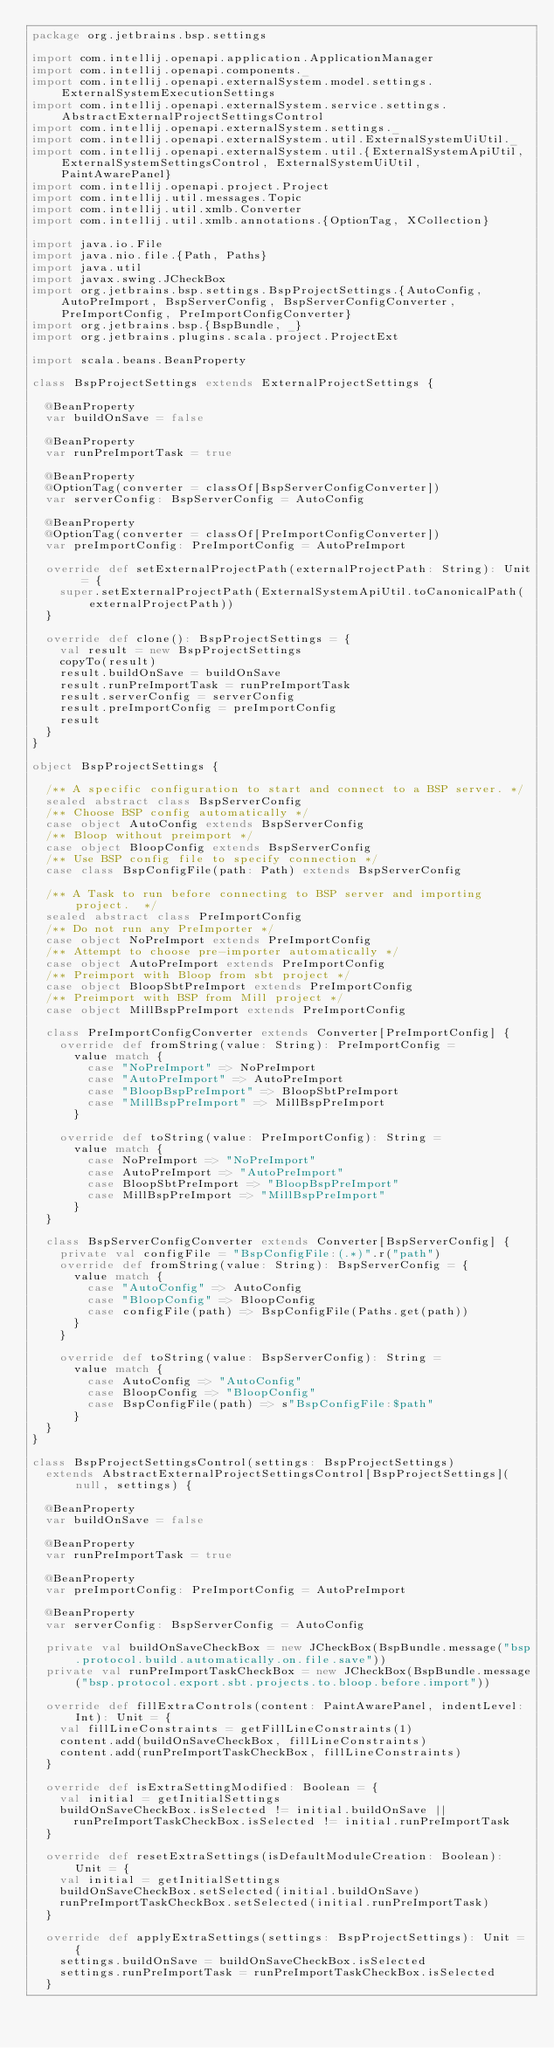<code> <loc_0><loc_0><loc_500><loc_500><_Scala_>package org.jetbrains.bsp.settings

import com.intellij.openapi.application.ApplicationManager
import com.intellij.openapi.components._
import com.intellij.openapi.externalSystem.model.settings.ExternalSystemExecutionSettings
import com.intellij.openapi.externalSystem.service.settings.AbstractExternalProjectSettingsControl
import com.intellij.openapi.externalSystem.settings._
import com.intellij.openapi.externalSystem.util.ExternalSystemUiUtil._
import com.intellij.openapi.externalSystem.util.{ExternalSystemApiUtil, ExternalSystemSettingsControl, ExternalSystemUiUtil, PaintAwarePanel}
import com.intellij.openapi.project.Project
import com.intellij.util.messages.Topic
import com.intellij.util.xmlb.Converter
import com.intellij.util.xmlb.annotations.{OptionTag, XCollection}

import java.io.File
import java.nio.file.{Path, Paths}
import java.util
import javax.swing.JCheckBox
import org.jetbrains.bsp.settings.BspProjectSettings.{AutoConfig, AutoPreImport, BspServerConfig, BspServerConfigConverter, PreImportConfig, PreImportConfigConverter}
import org.jetbrains.bsp.{BspBundle, _}
import org.jetbrains.plugins.scala.project.ProjectExt

import scala.beans.BeanProperty

class BspProjectSettings extends ExternalProjectSettings {

  @BeanProperty
  var buildOnSave = false

  @BeanProperty
  var runPreImportTask = true

  @BeanProperty
  @OptionTag(converter = classOf[BspServerConfigConverter])
  var serverConfig: BspServerConfig = AutoConfig

  @BeanProperty
  @OptionTag(converter = classOf[PreImportConfigConverter])
  var preImportConfig: PreImportConfig = AutoPreImport

  override def setExternalProjectPath(externalProjectPath: String): Unit = {
    super.setExternalProjectPath(ExternalSystemApiUtil.toCanonicalPath(externalProjectPath))
  }

  override def clone(): BspProjectSettings = {
    val result = new BspProjectSettings
    copyTo(result)
    result.buildOnSave = buildOnSave
    result.runPreImportTask = runPreImportTask
    result.serverConfig = serverConfig
    result.preImportConfig = preImportConfig
    result
  }
}

object BspProjectSettings {

  /** A specific configuration to start and connect to a BSP server. */
  sealed abstract class BspServerConfig
  /** Choose BSP config automatically */
  case object AutoConfig extends BspServerConfig
  /** Bloop without preimport */
  case object BloopConfig extends BspServerConfig
  /** Use BSP config file to specify connection */
  case class BspConfigFile(path: Path) extends BspServerConfig

  /** A Task to run before connecting to BSP server and importing project.  */
  sealed abstract class PreImportConfig
  /** Do not run any PreImporter */
  case object NoPreImport extends PreImportConfig
  /** Attempt to choose pre-importer automatically */
  case object AutoPreImport extends PreImportConfig
  /** Preimport with Bloop from sbt project */
  case object BloopSbtPreImport extends PreImportConfig
  /** Preimport with BSP from Mill project */
  case object MillBspPreImport extends PreImportConfig

  class PreImportConfigConverter extends Converter[PreImportConfig] {
    override def fromString(value: String): PreImportConfig =
      value match {
        case "NoPreImport" => NoPreImport
        case "AutoPreImport" => AutoPreImport
        case "BloopBspPreImport" => BloopSbtPreImport
        case "MillBspPreImport" => MillBspPreImport
      }

    override def toString(value: PreImportConfig): String =
      value match {
        case NoPreImport => "NoPreImport"
        case AutoPreImport => "AutoPreImport"
        case BloopSbtPreImport => "BloopBspPreImport"
        case MillBspPreImport => "MillBspPreImport"
      }
  }

  class BspServerConfigConverter extends Converter[BspServerConfig] {
    private val configFile = "BspConfigFile:(.*)".r("path")
    override def fromString(value: String): BspServerConfig = {
      value match {
        case "AutoConfig" => AutoConfig
        case "BloopConfig" => BloopConfig
        case configFile(path) => BspConfigFile(Paths.get(path))
      }
    }

    override def toString(value: BspServerConfig): String =
      value match {
        case AutoConfig => "AutoConfig"
        case BloopConfig => "BloopConfig"
        case BspConfigFile(path) => s"BspConfigFile:$path"
      }
  }
}

class BspProjectSettingsControl(settings: BspProjectSettings)
  extends AbstractExternalProjectSettingsControl[BspProjectSettings](null, settings) {

  @BeanProperty
  var buildOnSave = false

  @BeanProperty
  var runPreImportTask = true

  @BeanProperty
  var preImportConfig: PreImportConfig = AutoPreImport

  @BeanProperty
  var serverConfig: BspServerConfig = AutoConfig

  private val buildOnSaveCheckBox = new JCheckBox(BspBundle.message("bsp.protocol.build.automatically.on.file.save"))
  private val runPreImportTaskCheckBox = new JCheckBox(BspBundle.message("bsp.protocol.export.sbt.projects.to.bloop.before.import"))

  override def fillExtraControls(content: PaintAwarePanel, indentLevel: Int): Unit = {
    val fillLineConstraints = getFillLineConstraints(1)
    content.add(buildOnSaveCheckBox, fillLineConstraints)
    content.add(runPreImportTaskCheckBox, fillLineConstraints)
  }

  override def isExtraSettingModified: Boolean = {
    val initial = getInitialSettings
    buildOnSaveCheckBox.isSelected != initial.buildOnSave ||
      runPreImportTaskCheckBox.isSelected != initial.runPreImportTask
  }

  override def resetExtraSettings(isDefaultModuleCreation: Boolean): Unit = {
    val initial = getInitialSettings
    buildOnSaveCheckBox.setSelected(initial.buildOnSave)
    runPreImportTaskCheckBox.setSelected(initial.runPreImportTask)
  }

  override def applyExtraSettings(settings: BspProjectSettings): Unit = {
    settings.buildOnSave = buildOnSaveCheckBox.isSelected
    settings.runPreImportTask = runPreImportTaskCheckBox.isSelected
  }
</code> 